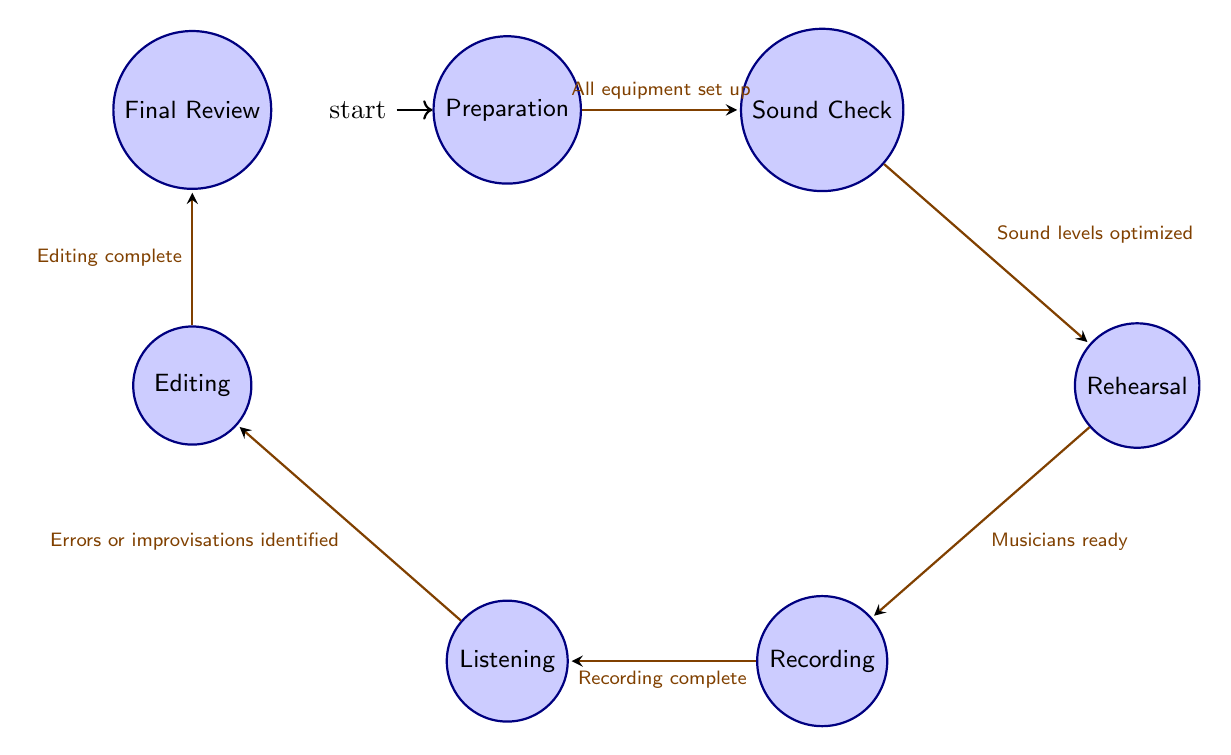What is the initial state in the diagram? The diagram indicates "Preparation" is the initial state as it is marked as the starting point for the workflow.
Answer: Preparation How many states are present in the diagram? By counting the states listed, we find seven distinct states: Preparation, Sound Check, Rehearsal, Recording, Listening, Editing, and Final Review.
Answer: Seven What is the trigger for transitioning from Sound Check to Rehearsal? The diagram specifies that the transition from Sound Check to Rehearsal occurs with the trigger "Sound levels optimized," which indicates a successful sound check.
Answer: Sound levels optimized Identify the state that follows Recording. Following the state of Recording, the next state is Listening, as indicated by the transition in the diagram.
Answer: Listening What is the final state in the workflow? The final state listed in the diagram is "Final Review," which concludes the recording session workflow after all editing is complete.
Answer: Final Review How many transitions are present in the diagram? The diagram includes six transitions between different states, showcasing the flow between each part of the recording process.
Answer: Six Which state has the trigger "All equipment set up"? The transition with the trigger "All equipment set up" leads from Preparation to Sound Check, indicating that this trigger is relevant to the state Preparation.
Answer: Preparation What transitions occur after Listening? After Listening, the transition occurs to Editing, which happens when errors or improvisations are identified during the listening phase of the workflow.
Answer: Editing 